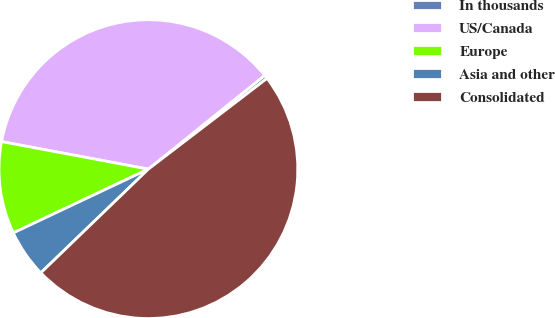<chart> <loc_0><loc_0><loc_500><loc_500><pie_chart><fcel>In thousands<fcel>US/Canada<fcel>Europe<fcel>Asia and other<fcel>Consolidated<nl><fcel>0.41%<fcel>36.25%<fcel>9.97%<fcel>5.19%<fcel>48.18%<nl></chart> 